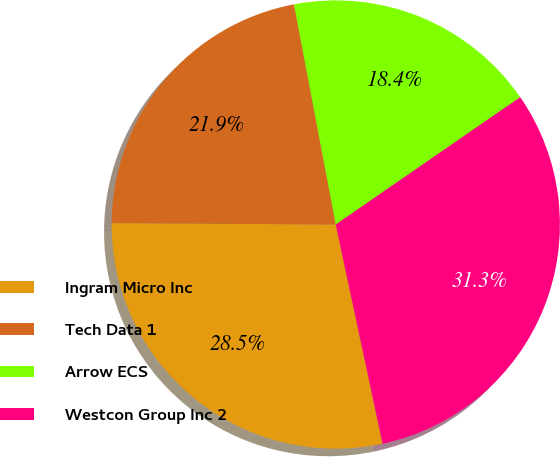<chart> <loc_0><loc_0><loc_500><loc_500><pie_chart><fcel>Ingram Micro Inc<fcel>Tech Data 1<fcel>Arrow ECS<fcel>Westcon Group Inc 2<nl><fcel>28.45%<fcel>21.91%<fcel>18.37%<fcel>31.27%<nl></chart> 